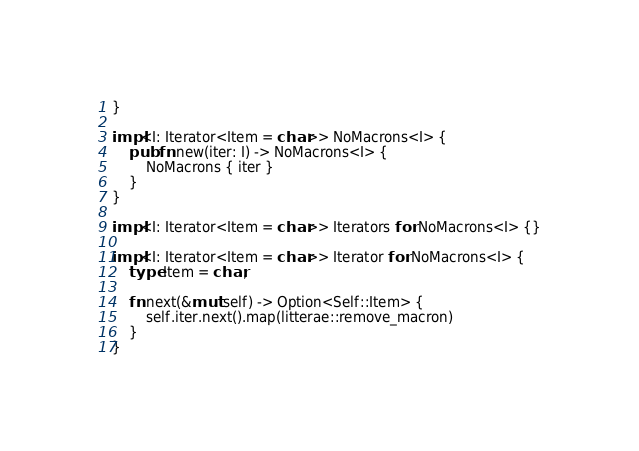Convert code to text. <code><loc_0><loc_0><loc_500><loc_500><_Rust_>}

impl<I: Iterator<Item = char>> NoMacrons<I> {
    pub fn new(iter: I) -> NoMacrons<I> {
        NoMacrons { iter }
    }
}

impl<I: Iterator<Item = char>> Iterators for NoMacrons<I> {}

impl<I: Iterator<Item = char>> Iterator for NoMacrons<I> {
    type Item = char;

    fn next(&mut self) -> Option<Self::Item> {
        self.iter.next().map(litterae::remove_macron)
    }
}
</code> 